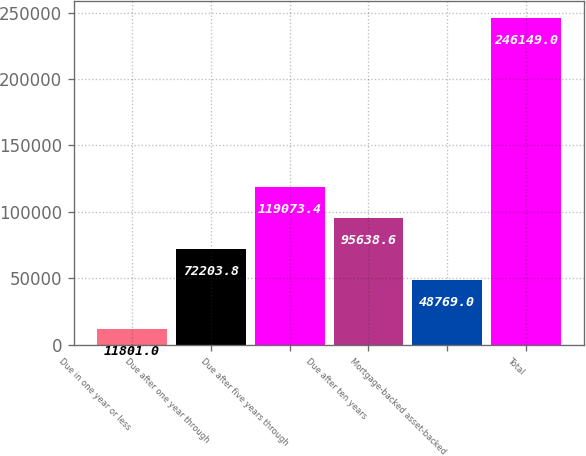Convert chart to OTSL. <chart><loc_0><loc_0><loc_500><loc_500><bar_chart><fcel>Due in one year or less<fcel>Due after one year through<fcel>Due after five years through<fcel>Due after ten years<fcel>Mortgage-backed asset-backed<fcel>Total<nl><fcel>11801<fcel>72203.8<fcel>119073<fcel>95638.6<fcel>48769<fcel>246149<nl></chart> 